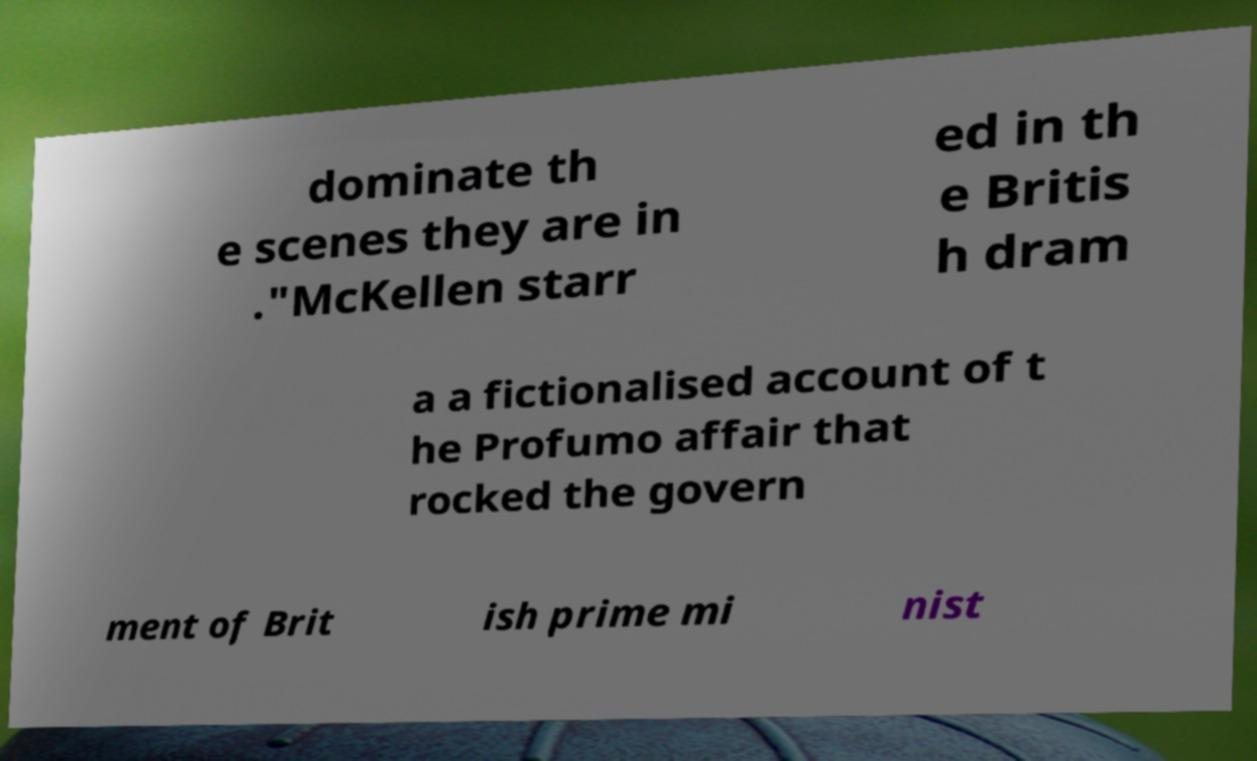What messages or text are displayed in this image? I need them in a readable, typed format. dominate th e scenes they are in ."McKellen starr ed in th e Britis h dram a a fictionalised account of t he Profumo affair that rocked the govern ment of Brit ish prime mi nist 